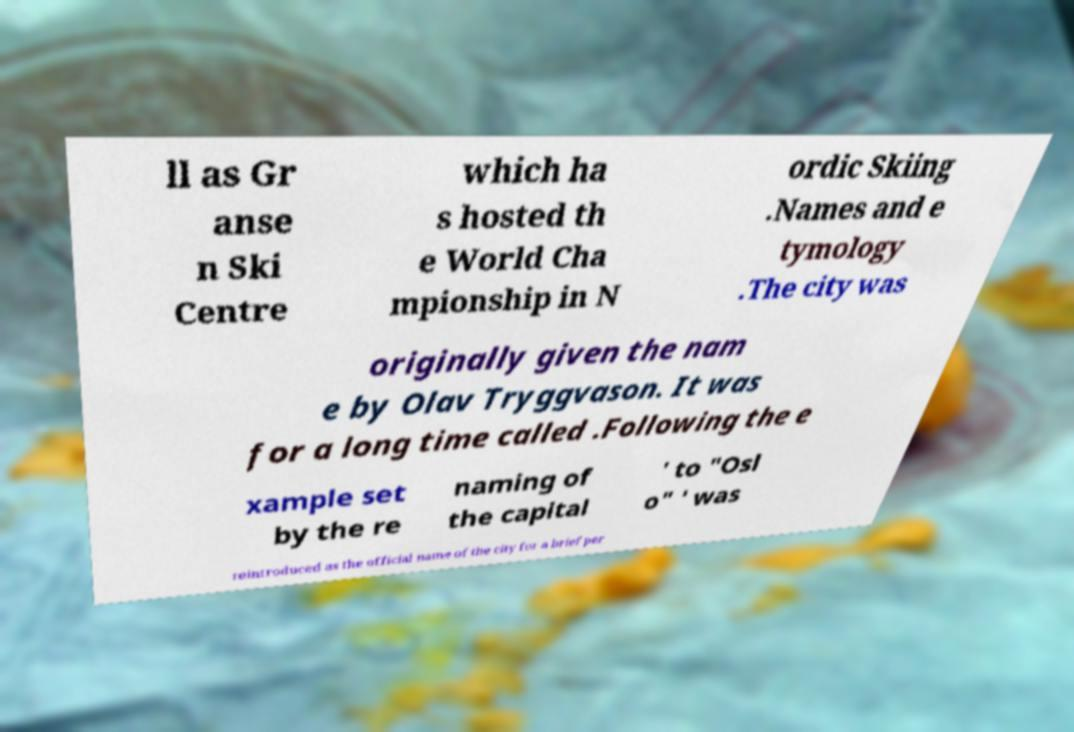Could you extract and type out the text from this image? ll as Gr anse n Ski Centre which ha s hosted th e World Cha mpionship in N ordic Skiing .Names and e tymology .The city was originally given the nam e by Olav Tryggvason. It was for a long time called .Following the e xample set by the re naming of the capital ' to "Osl o" ' was reintroduced as the official name of the city for a brief per 